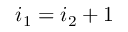Convert formula to latex. <formula><loc_0><loc_0><loc_500><loc_500>i _ { 1 } = i _ { 2 } + 1</formula> 